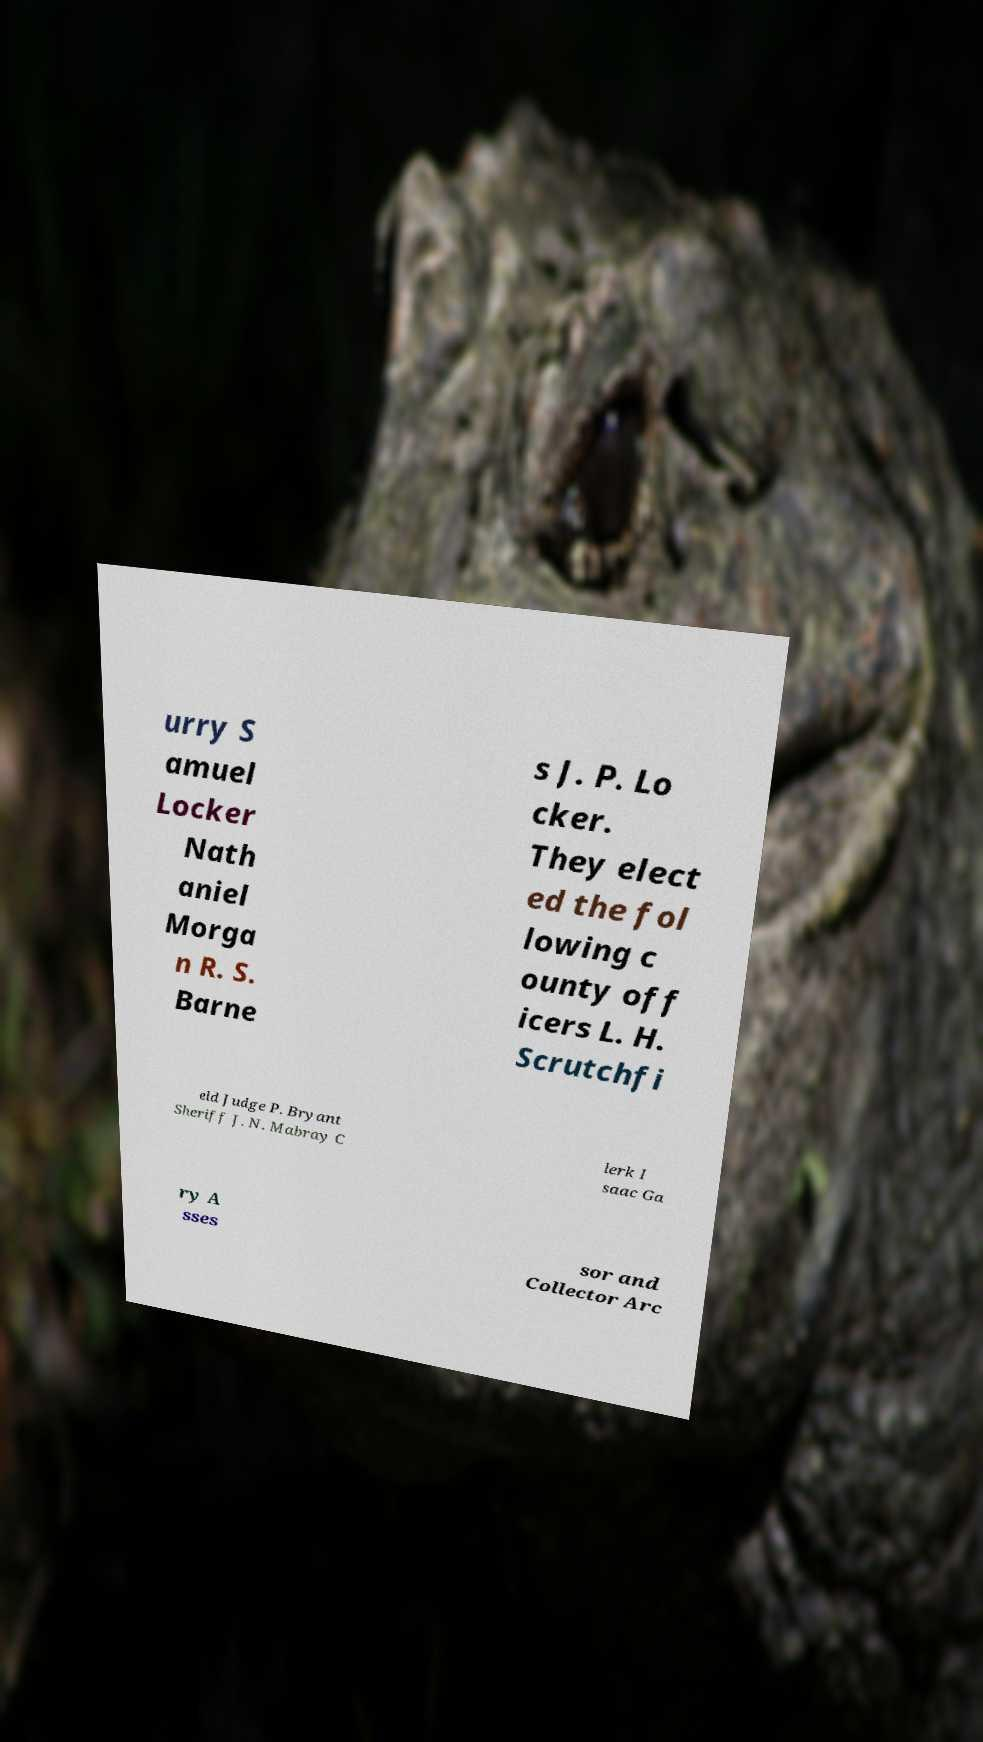Can you read and provide the text displayed in the image?This photo seems to have some interesting text. Can you extract and type it out for me? urry S amuel Locker Nath aniel Morga n R. S. Barne s J. P. Lo cker. They elect ed the fol lowing c ounty off icers L. H. Scrutchfi eld Judge P. Bryant Sheriff J. N. Mabray C lerk I saac Ga ry A sses sor and Collector Arc 